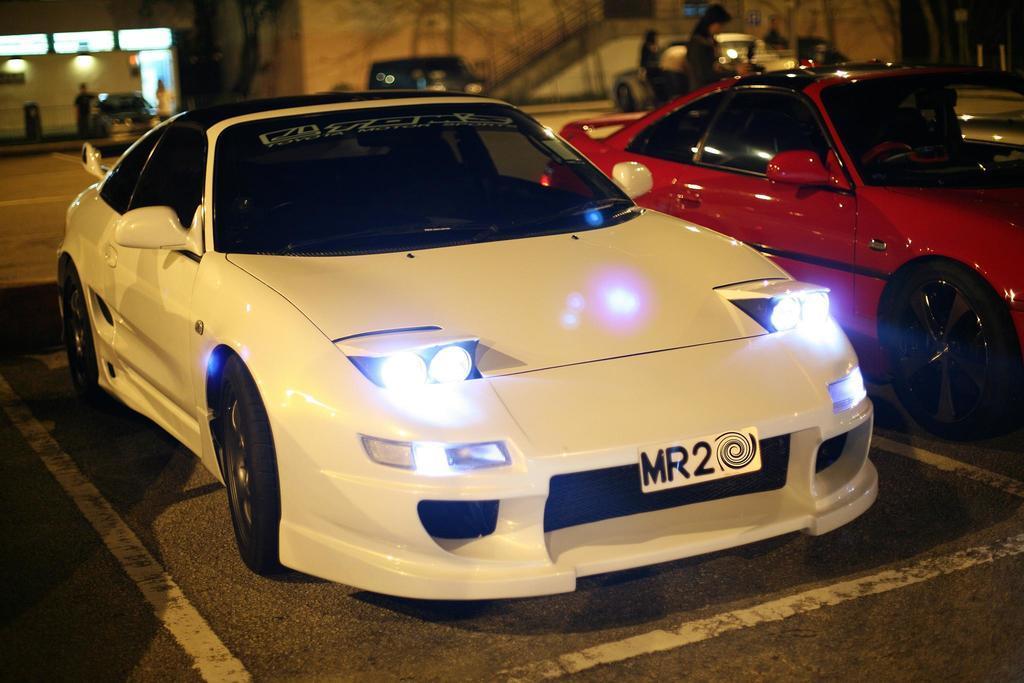Please provide a concise description of this image. In this picture I can see 2 cars in front and I see the road and in the background I see few more cars and few people and I see that it is blurred a bit and on the top left of this image I see the lights. 